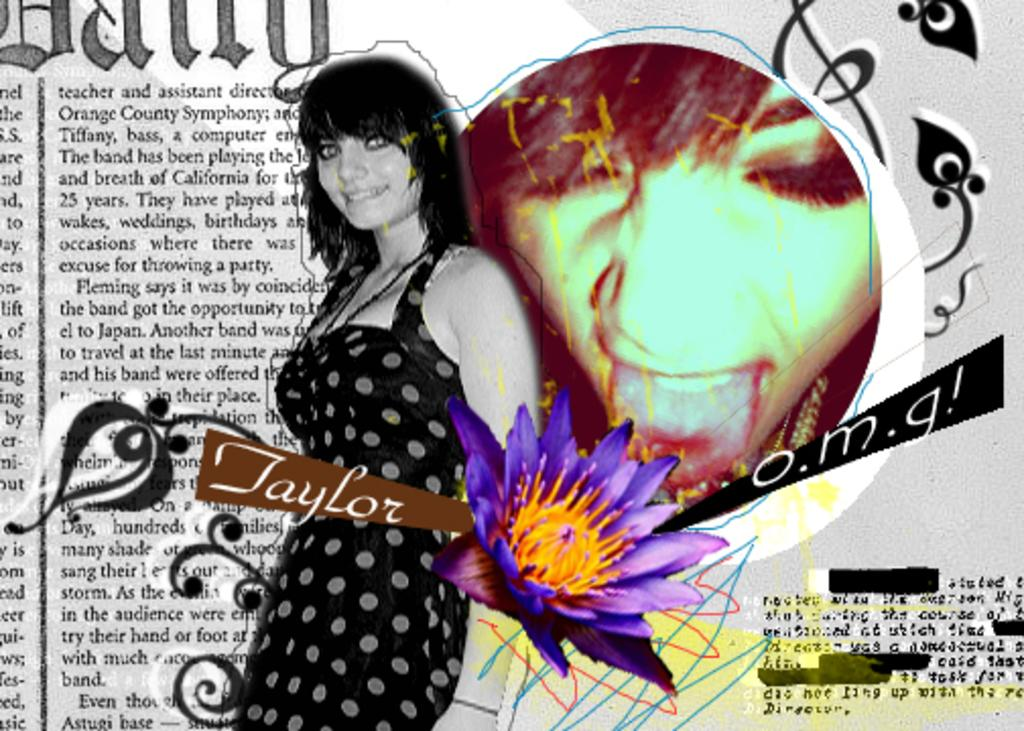Who is present in the image? There is a woman in the image. What is the woman doing in the image? The woman is standing and smiling. What can be seen in the image besides the woman? There is a purple color flower in the image. Is there any text or writing in the image? Yes, there is something written on the image. How many girls are playing with the wax in the image? There are no girls or wax present in the image. What type of care is the woman providing to the flower in the image? The image does not show the woman providing care to the flower; it only shows her standing and smiling. 